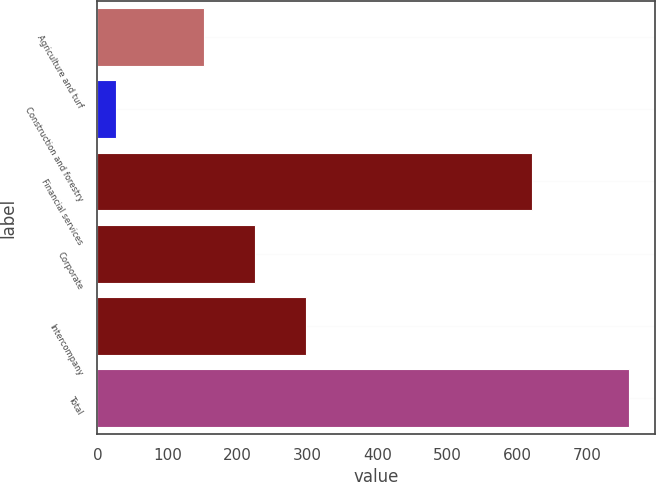<chart> <loc_0><loc_0><loc_500><loc_500><bar_chart><fcel>Agriculture and turf<fcel>Construction and forestry<fcel>Financial services<fcel>Corporate<fcel>Intercompany<fcel>Total<nl><fcel>152<fcel>26<fcel>621<fcel>225.3<fcel>298.6<fcel>759<nl></chart> 